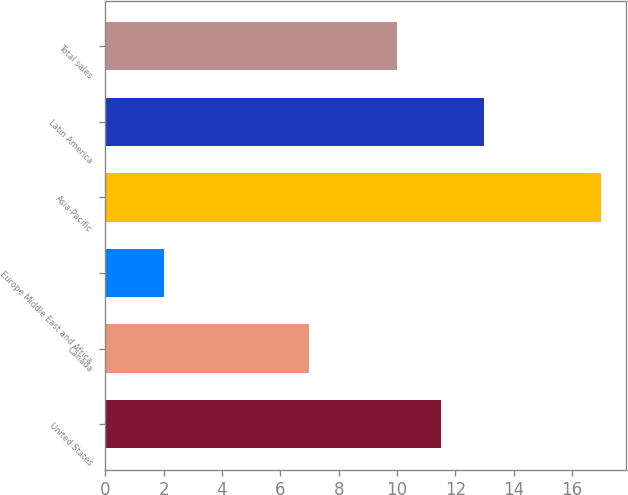<chart> <loc_0><loc_0><loc_500><loc_500><bar_chart><fcel>United States<fcel>Canada<fcel>Europe Middle East and Africa<fcel>Asia-Pacific<fcel>Latin America<fcel>Total sales<nl><fcel>11.5<fcel>7<fcel>2<fcel>17<fcel>13<fcel>10<nl></chart> 